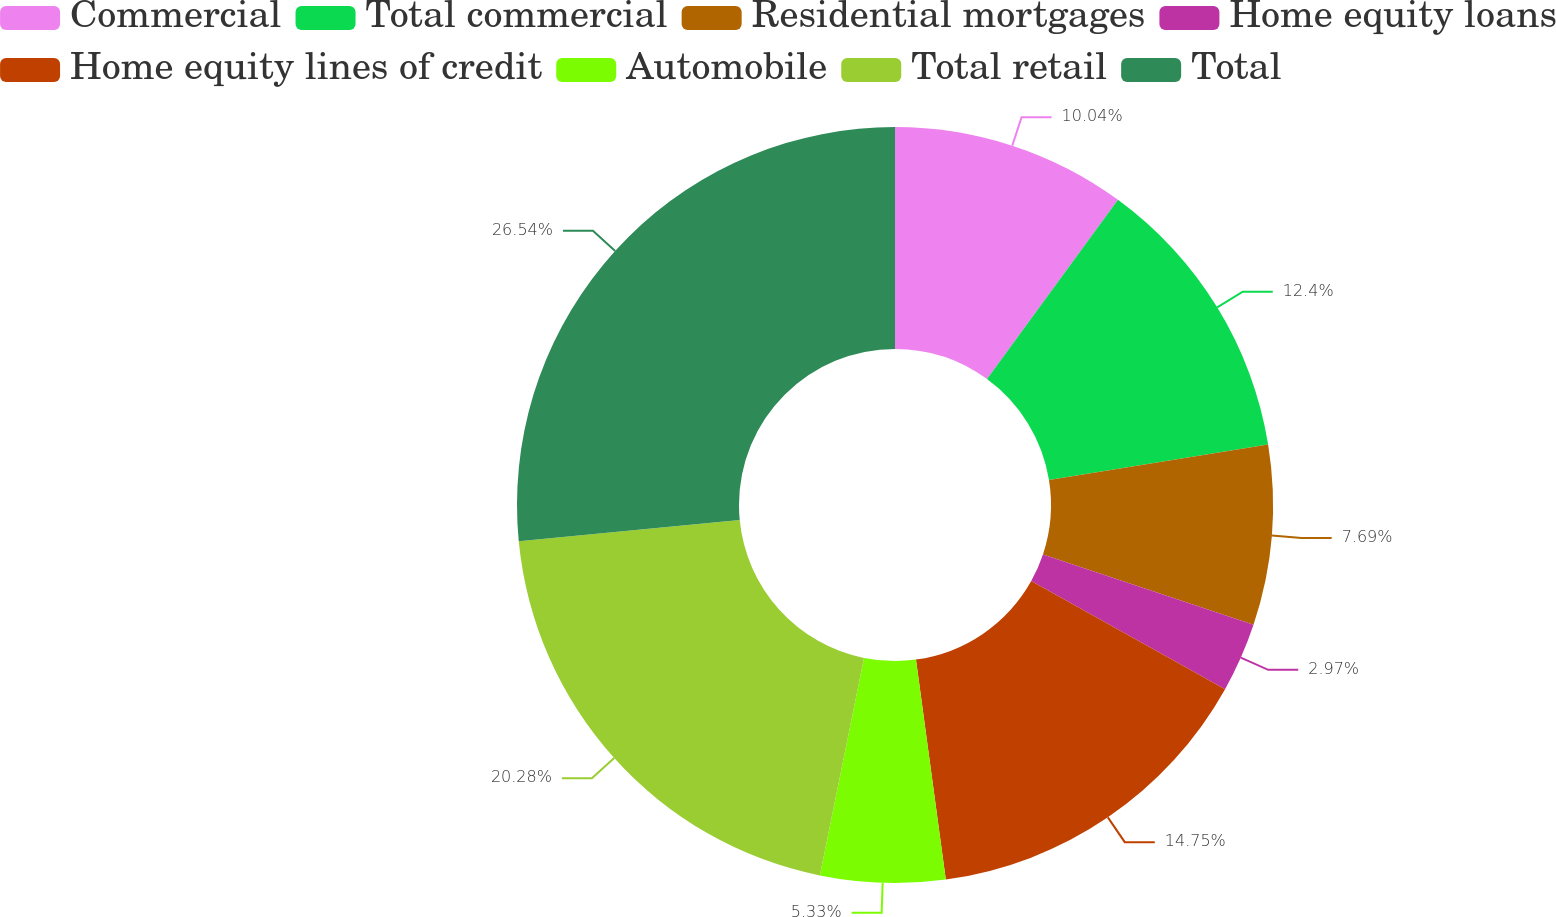Convert chart. <chart><loc_0><loc_0><loc_500><loc_500><pie_chart><fcel>Commercial<fcel>Total commercial<fcel>Residential mortgages<fcel>Home equity loans<fcel>Home equity lines of credit<fcel>Automobile<fcel>Total retail<fcel>Total<nl><fcel>10.04%<fcel>12.4%<fcel>7.69%<fcel>2.97%<fcel>14.75%<fcel>5.33%<fcel>20.28%<fcel>26.53%<nl></chart> 